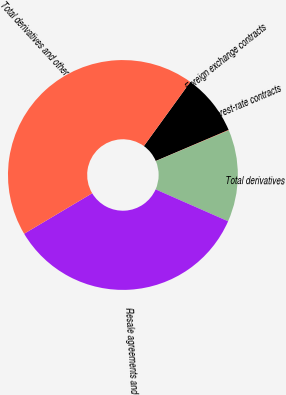<chart> <loc_0><loc_0><loc_500><loc_500><pie_chart><fcel>Foreign exchange contracts<fcel>Interest-rate contracts<fcel>Total derivatives<fcel>Resale agreements and<fcel>Total derivatives and other<nl><fcel>8.61%<fcel>0.05%<fcel>12.96%<fcel>34.86%<fcel>43.52%<nl></chart> 